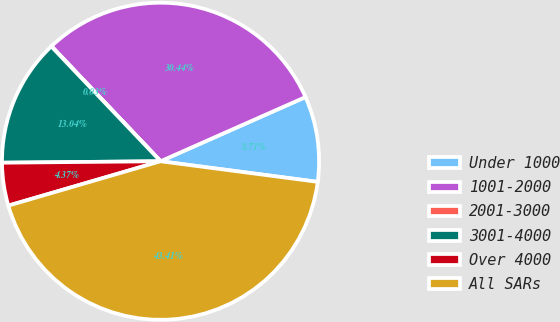Convert chart. <chart><loc_0><loc_0><loc_500><loc_500><pie_chart><fcel>Under 1000<fcel>1001-2000<fcel>2001-3000<fcel>3001-4000<fcel>Over 4000<fcel>All SARs<nl><fcel>8.71%<fcel>30.44%<fcel>0.03%<fcel>13.04%<fcel>4.37%<fcel>43.41%<nl></chart> 